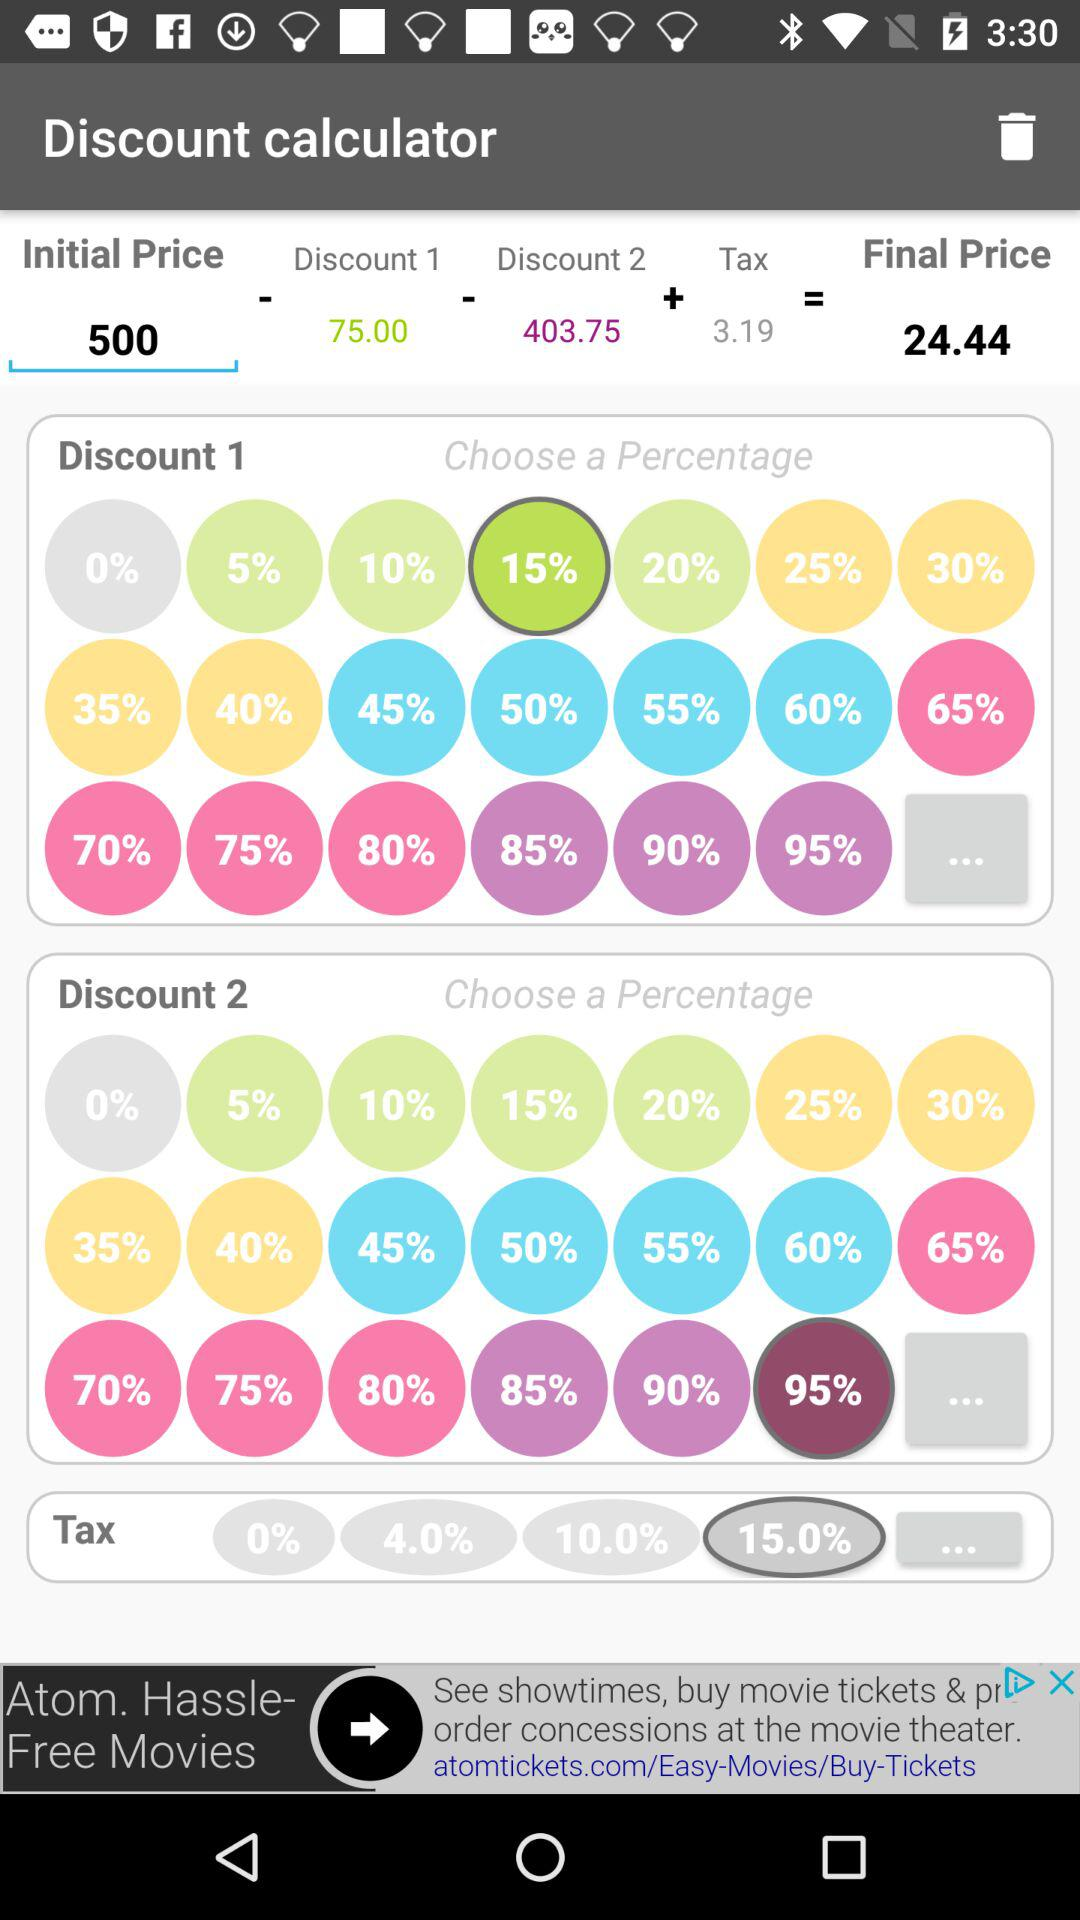What's the application name? The application name is "Discount calculator". 